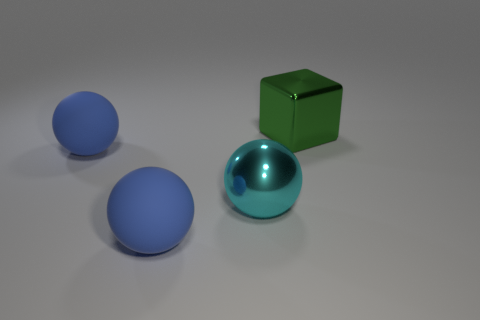Add 2 large blue matte objects. How many objects exist? 6 Subtract all balls. How many objects are left? 1 Add 3 big shiny things. How many big shiny things are left? 5 Add 2 big blue rubber spheres. How many big blue rubber spheres exist? 4 Subtract 0 brown spheres. How many objects are left? 4 Subtract all big objects. Subtract all tiny red matte things. How many objects are left? 0 